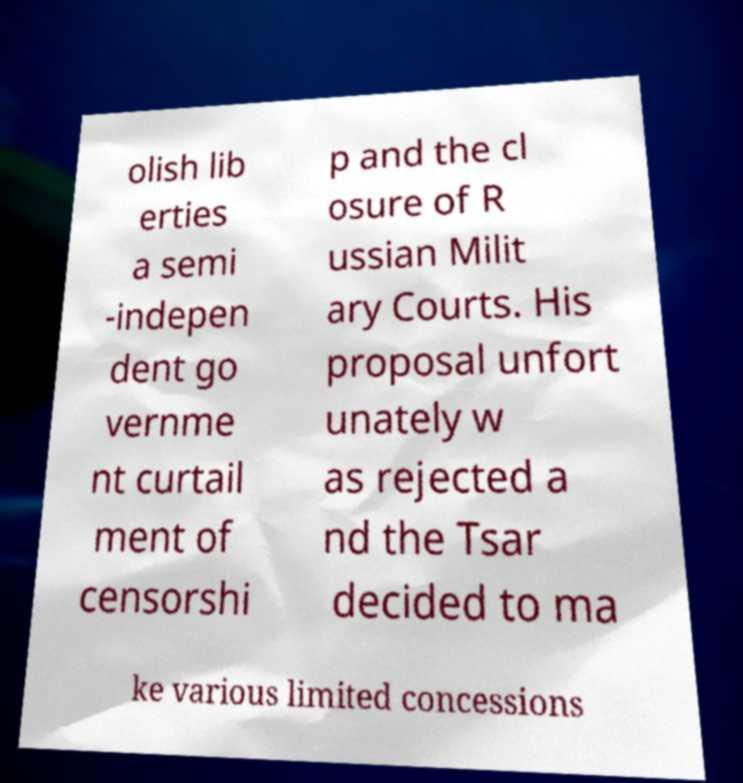I need the written content from this picture converted into text. Can you do that? olish lib erties a semi -indepen dent go vernme nt curtail ment of censorshi p and the cl osure of R ussian Milit ary Courts. His proposal unfort unately w as rejected a nd the Tsar decided to ma ke various limited concessions 